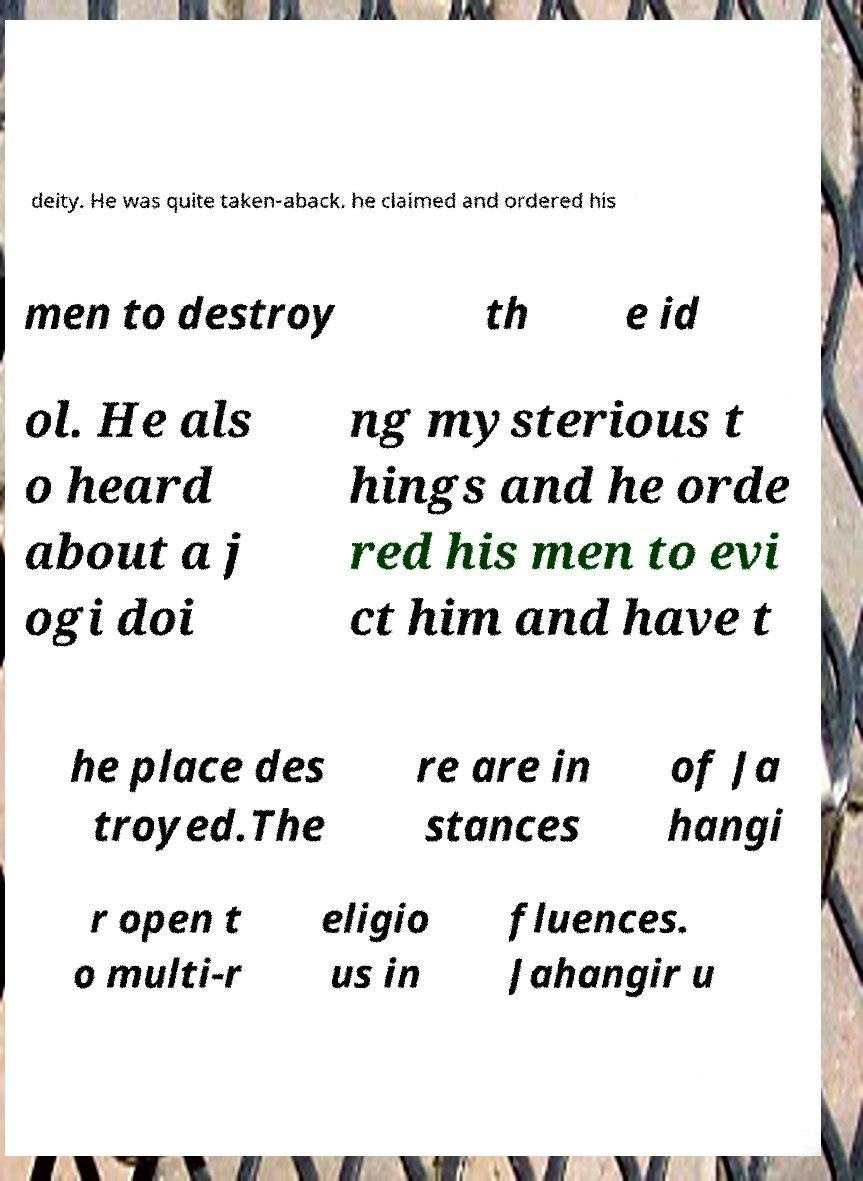Can you accurately transcribe the text from the provided image for me? deity. He was quite taken-aback. he claimed and ordered his men to destroy th e id ol. He als o heard about a j ogi doi ng mysterious t hings and he orde red his men to evi ct him and have t he place des troyed.The re are in stances of Ja hangi r open t o multi-r eligio us in fluences. Jahangir u 